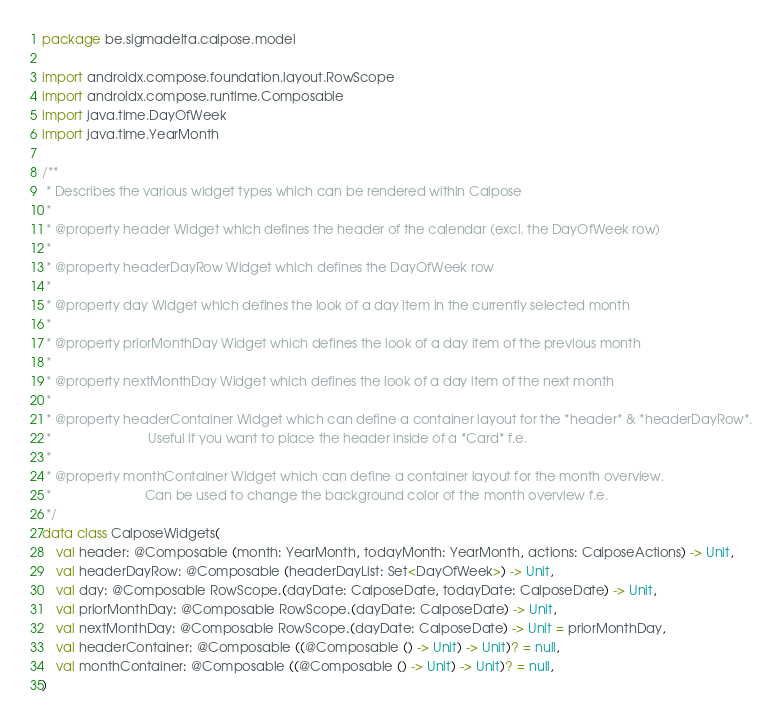Convert code to text. <code><loc_0><loc_0><loc_500><loc_500><_Kotlin_>package be.sigmadelta.calpose.model

import androidx.compose.foundation.layout.RowScope
import androidx.compose.runtime.Composable
import java.time.DayOfWeek
import java.time.YearMonth

/**
 * Describes the various widget types which can be rendered within Calpose
 *
 * @property header Widget which defines the header of the calendar (excl. the DayOfWeek row)
 *
 * @property headerDayRow Widget which defines the DayOfWeek row
 *
 * @property day Widget which defines the look of a day item in the currently selected month
 *
 * @property priorMonthDay Widget which defines the look of a day item of the previous month
 *
 * @property nextMonthDay Widget which defines the look of a day item of the next month
 *
 * @property headerContainer Widget which can define a container layout for the *header* & *headerDayRow*.
 *                           Useful if you want to place the header inside of a *Card* f.e.
 *
 * @property monthContainer Widget which can define a container layout for the month overview.
 *                          Can be used to change the background color of the month overview f.e.
 */
data class CalposeWidgets(
    val header: @Composable (month: YearMonth, todayMonth: YearMonth, actions: CalposeActions) -> Unit,
    val headerDayRow: @Composable (headerDayList: Set<DayOfWeek>) -> Unit,
    val day: @Composable RowScope.(dayDate: CalposeDate, todayDate: CalposeDate) -> Unit,
    val priorMonthDay: @Composable RowScope.(dayDate: CalposeDate) -> Unit,
    val nextMonthDay: @Composable RowScope.(dayDate: CalposeDate) -> Unit = priorMonthDay,
    val headerContainer: @Composable ((@Composable () -> Unit) -> Unit)? = null,
    val monthContainer: @Composable ((@Composable () -> Unit) -> Unit)? = null,
)</code> 